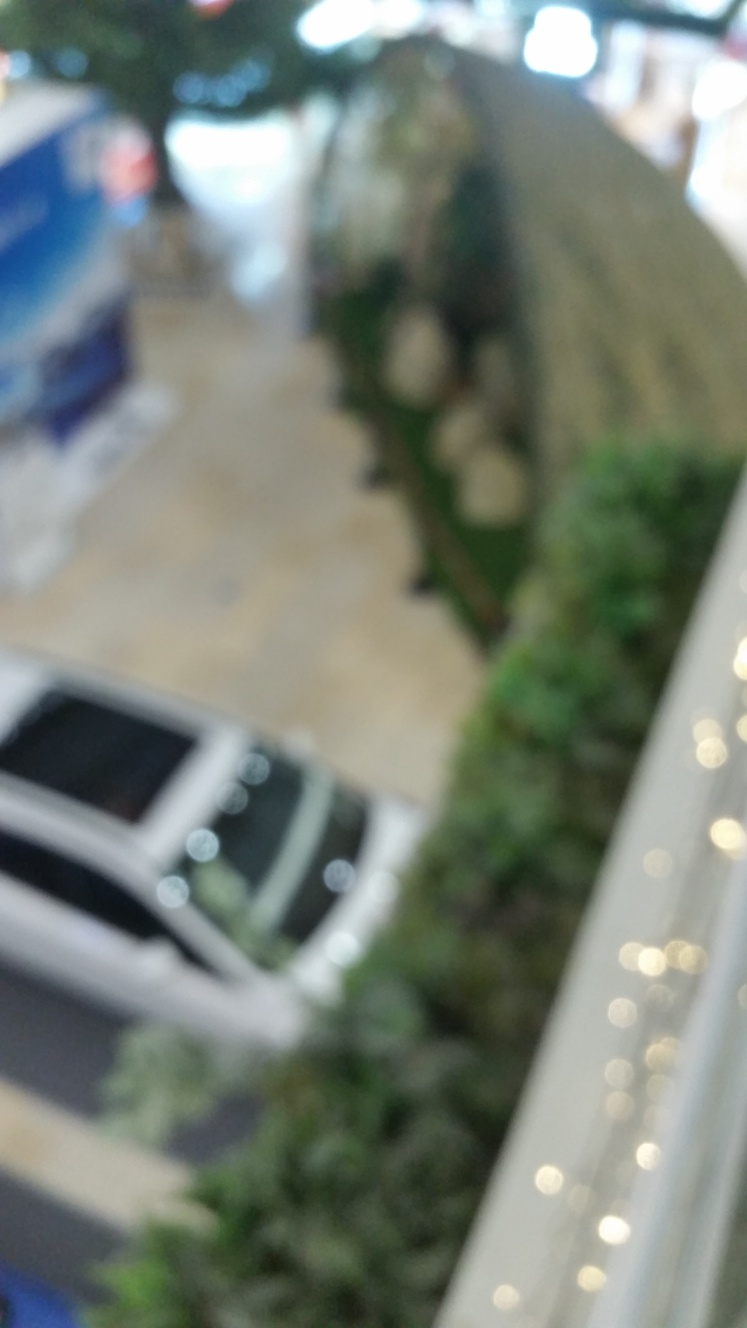Can you describe what this place might be? Given the blurry nature of this image, it's challenging to provide specifics. However, the image suggests an indoor area with multiple levels, probably a public space like a shopping center or a complex with a mix of retail and leisure facilities. The bright lighting and reflective surfaces hint at a modern, possibly urban environment. What can be improved to make this a better image? To enhance this image, adjusting the focus to ensure sharpness would be essential. Proper lighting balance and stabilization during shooting could also improve the overall quality. If the blurriness is due to motion, a faster shutter speed might help capture a crisper image. 